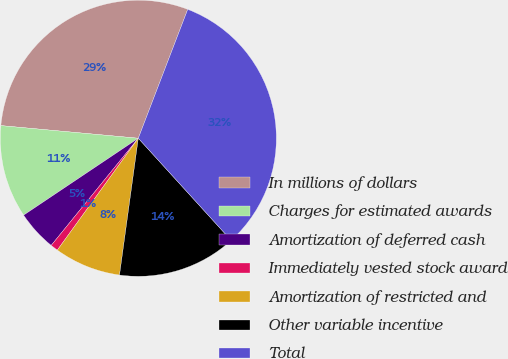Convert chart to OTSL. <chart><loc_0><loc_0><loc_500><loc_500><pie_chart><fcel>In millions of dollars<fcel>Charges for estimated awards<fcel>Amortization of deferred cash<fcel>Immediately vested stock award<fcel>Amortization of restricted and<fcel>Other variable incentive<fcel>Total<nl><fcel>29.37%<fcel>10.86%<fcel>4.74%<fcel>0.89%<fcel>7.8%<fcel>13.92%<fcel>32.43%<nl></chart> 